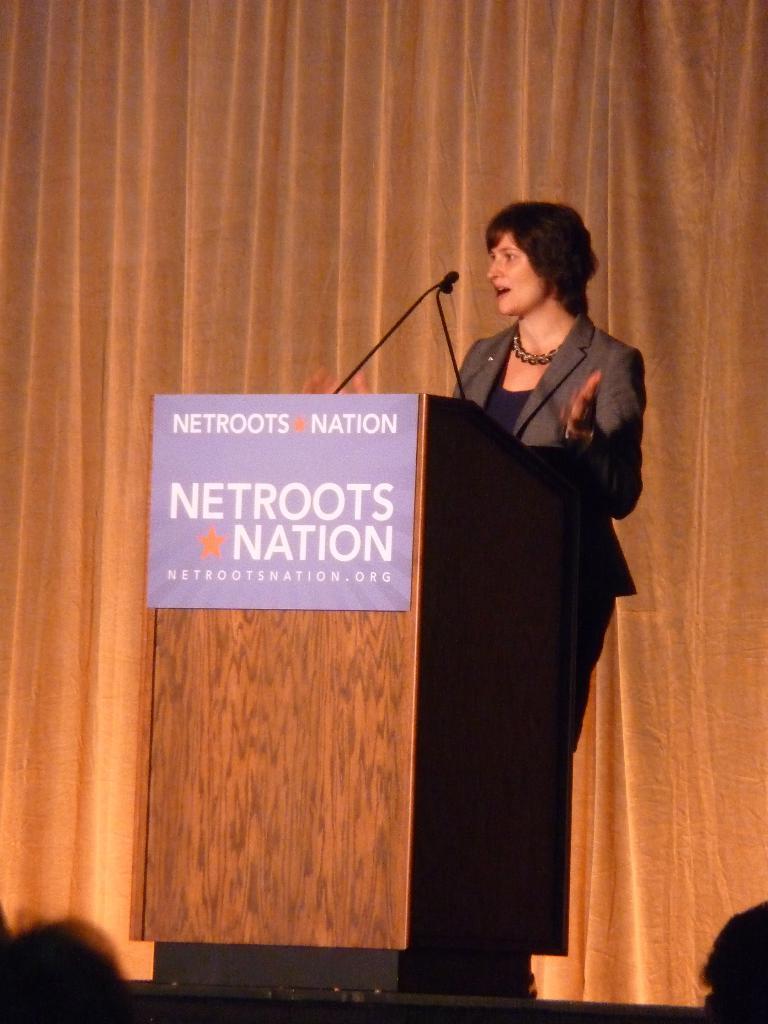What is the name of the organization on the podium?
Offer a terse response. Netroots nation. 